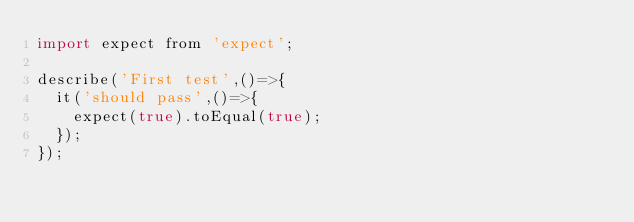Convert code to text. <code><loc_0><loc_0><loc_500><loc_500><_JavaScript_>import expect from 'expect';

describe('First test',()=>{
  it('should pass',()=>{
    expect(true).toEqual(true);
  });
});
</code> 